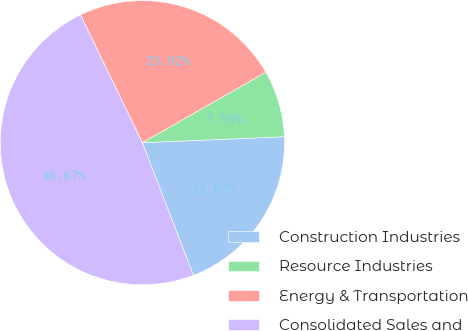Convert chart to OTSL. <chart><loc_0><loc_0><loc_500><loc_500><pie_chart><fcel>Construction Industries<fcel>Resource Industries<fcel>Energy & Transportation<fcel>Consolidated Sales and<nl><fcel>19.82%<fcel>7.59%<fcel>23.92%<fcel>48.67%<nl></chart> 